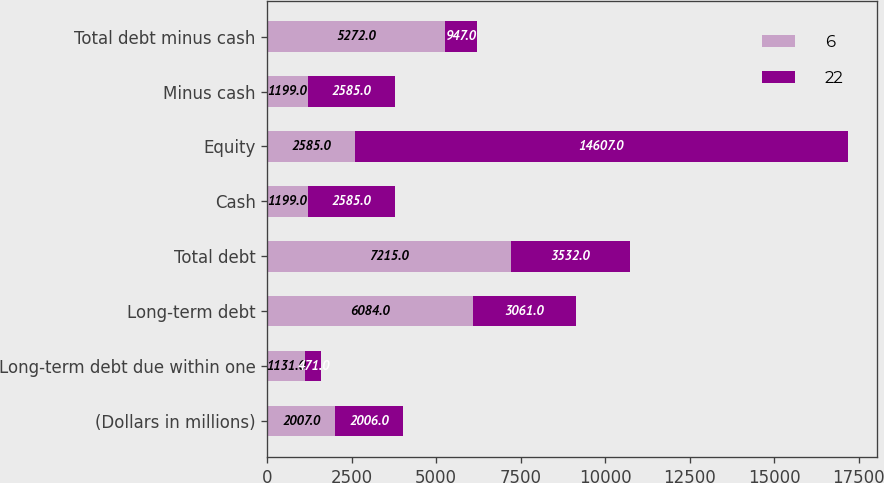Convert chart. <chart><loc_0><loc_0><loc_500><loc_500><stacked_bar_chart><ecel><fcel>(Dollars in millions)<fcel>Long-term debt due within one<fcel>Long-term debt<fcel>Total debt<fcel>Cash<fcel>Equity<fcel>Minus cash<fcel>Total debt minus cash<nl><fcel>6<fcel>2007<fcel>1131<fcel>6084<fcel>7215<fcel>1199<fcel>2585<fcel>1199<fcel>5272<nl><fcel>22<fcel>2006<fcel>471<fcel>3061<fcel>3532<fcel>2585<fcel>14607<fcel>2585<fcel>947<nl></chart> 